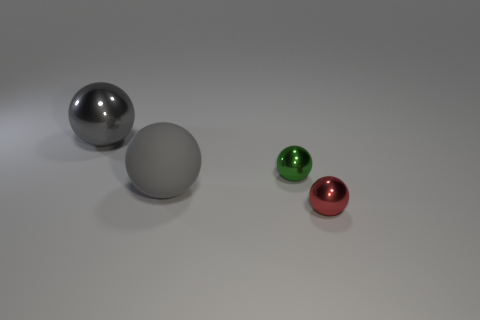Is the number of spheres behind the large gray rubber object less than the number of red objects that are on the right side of the small red metallic object?
Provide a succinct answer. No. There is another big object that is the same color as the big metal object; what is it made of?
Provide a short and direct response. Rubber. What color is the big shiny sphere that is to the left of the tiny red shiny sphere?
Make the answer very short. Gray. Do the big shiny ball and the rubber thing have the same color?
Make the answer very short. Yes. There is a gray thing on the right side of the gray sphere that is behind the large rubber thing; what number of small objects are behind it?
Make the answer very short. 1. The green metallic ball is what size?
Offer a terse response. Small. There is a sphere that is the same size as the green metallic object; what is it made of?
Provide a succinct answer. Metal. What number of large matte things are on the right side of the tiny green metal sphere?
Keep it short and to the point. 0. Does the gray ball that is behind the green metallic sphere have the same material as the tiny object in front of the small green object?
Your answer should be compact. Yes. There is a big object that is in front of the gray ball behind the gray ball on the right side of the large gray shiny thing; what shape is it?
Ensure brevity in your answer.  Sphere. 